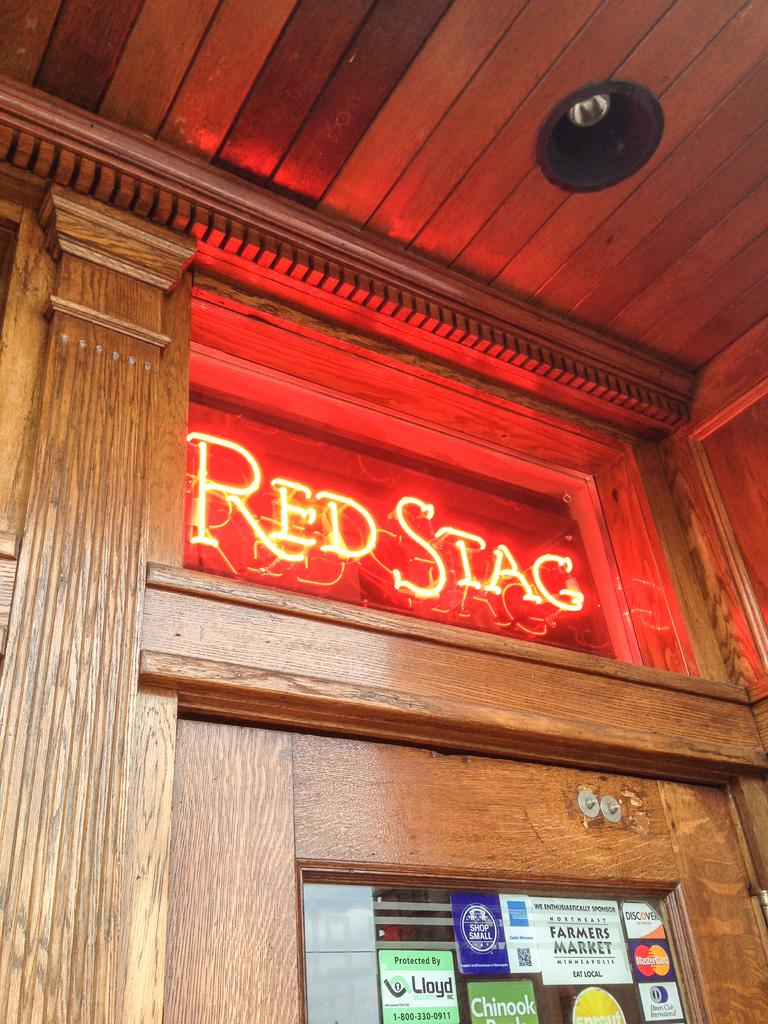What type of material is used for the wall in the image? There is a wooden wall in the image. What electronic device is present in the image? There is an LED board in the image. What is on the transparent glass in the image? There are stickers on a transparent glass in the image. What can be seen providing illumination in the image? There are lights visible in the image. What type of scarf is draped over the wooden wall in the image? There is no scarf present in the image; it features a wooden wall, an LED board, stickers on a transparent glass, and lights. What type of drink is being served on the LED board in the image? There is no drink present in the image; it features an LED board, but no drinks are visible. 